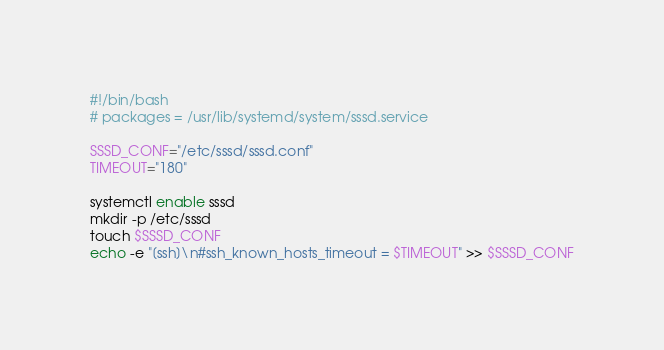Convert code to text. <code><loc_0><loc_0><loc_500><loc_500><_Bash_>#!/bin/bash
# packages = /usr/lib/systemd/system/sssd.service

SSSD_CONF="/etc/sssd/sssd.conf"
TIMEOUT="180"

systemctl enable sssd
mkdir -p /etc/sssd
touch $SSSD_CONF
echo -e "[ssh]\n#ssh_known_hosts_timeout = $TIMEOUT" >> $SSSD_CONF
</code> 